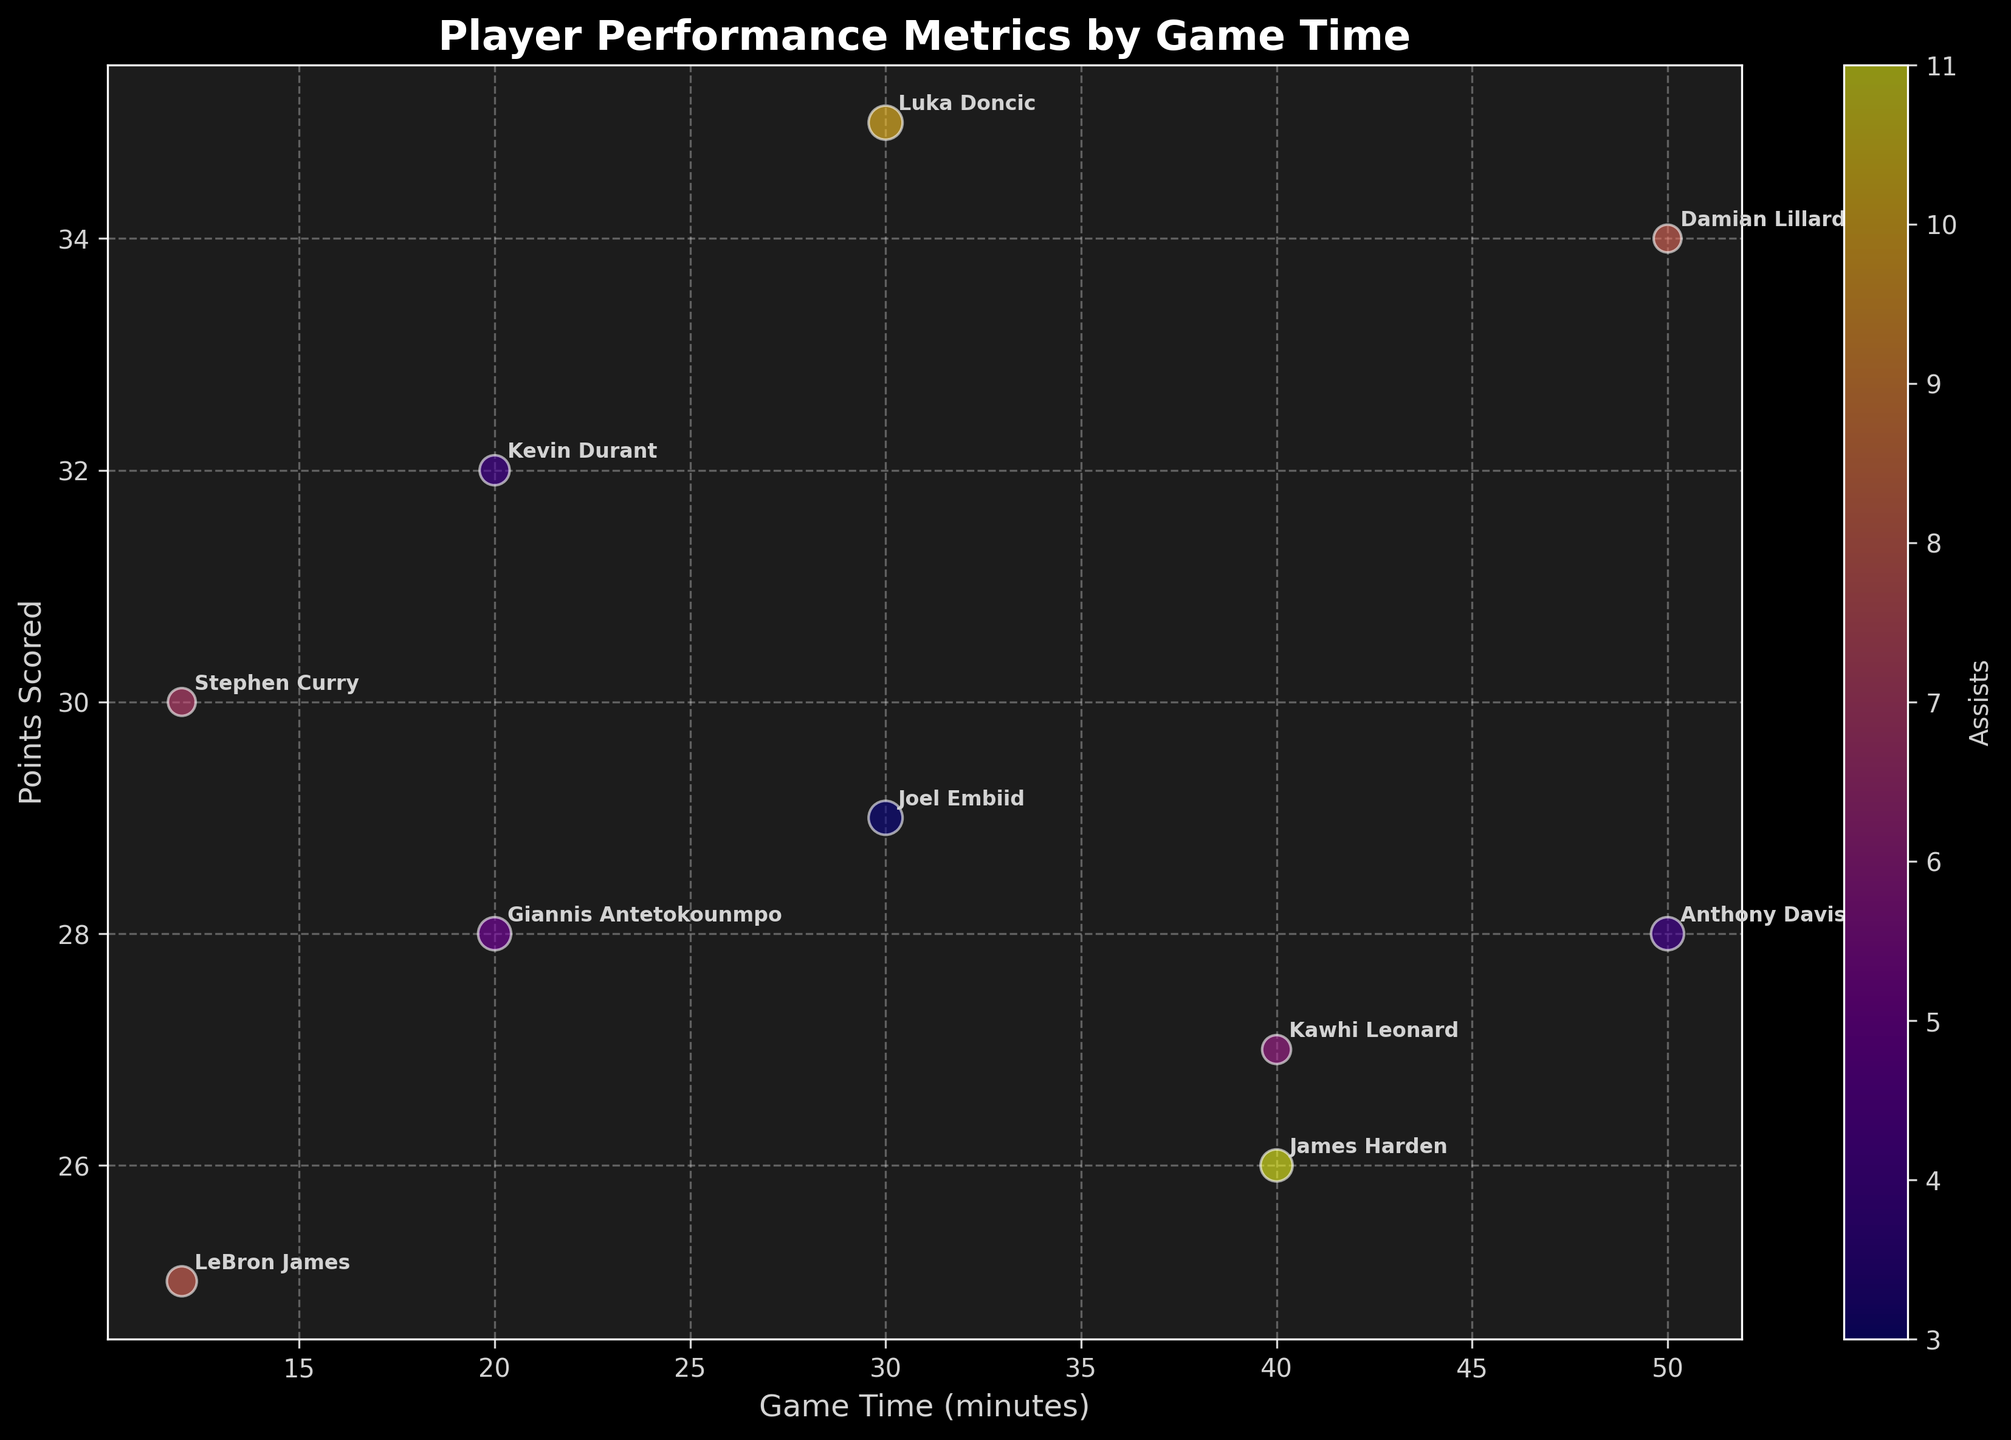What's the title of the chart? The title of the chart is usually placed at the top of the figure. It summarizes the main subject of the visual representation.
Answer: Player Performance Metrics by Game Time What are the labels of the X and Y axes? The X and Y axes are indicated to help interpret the figure. The X-axis is labeled 'Game Time (minutes)' and the Y-axis is labeled 'Points Scored'.
Answer: Game Time (minutes) and Points Scored How many players are represented in the chart? Count each unique player name annotated on the chart. Each annotation represents a player. There are 10 unique player names visible on the chart.
Answer: 10 Which player scored the most points and how many? Look at the Y-axis (Points Scored) and check the highest bubble in that direction. Luka Doncic's bubble reaches the highest point at 35 points.
Answer: Luka Doncic, 35 Who provided the most assists and how many? Identify the player whose bubble has the color representing the highest value on the color bar. James Harden's bubble is the most vibrant on the color bar (plasma colormap), indicating he provided 11 assists.
Answer: James Harden, 11 Which player has the largest bubble and what does it represent? The size of the bubble represents the sum of rebounds and assists. The largest bubble size represents Anthony Davis with 13 rebounds and 4 assists, totaling 17, so the largest bubble is Anthony Davis'.
Answer: Anthony Davis Whose bubble crossed the 30 minutes game time mark while also scoring over 30 points? Find bubbles that are positioned beyond the 30 on the X-axis and above 30 on the Y-axis simultaneously. Only Damian Lillard's bubble fits this description with 34 points.
Answer: Damian Lillard Which players played exactly 20 minutes and how do their scores compare? Check for bubbles on the 20-minute mark on the X-axis and compare their Y-axis positions. Kevin Durant scored 32 points, while Giannis Antetokounmpo scored 28 points.
Answer: Kevin Durant scored higher than Giannis Antetokounmpo What is the total number of assists by players who played 50 minutes? Check bubbles located on the 50 minute mark and sum their assist numbers. Anthony Davis provided 4 assists and Damian Lillard provided 8 assists. Total is 4 + 8 = 12.
Answer: 12 Compare the rebounds for players who played 30 minutes. Who had more? Look at the bubbles at the 30-minute mark on the X-axis and compare their rebounds. Luka Doncic had 8 rebounds, while Joel Embiid had 15 rebounds.
Answer: Joel Embiid had more rebounds 